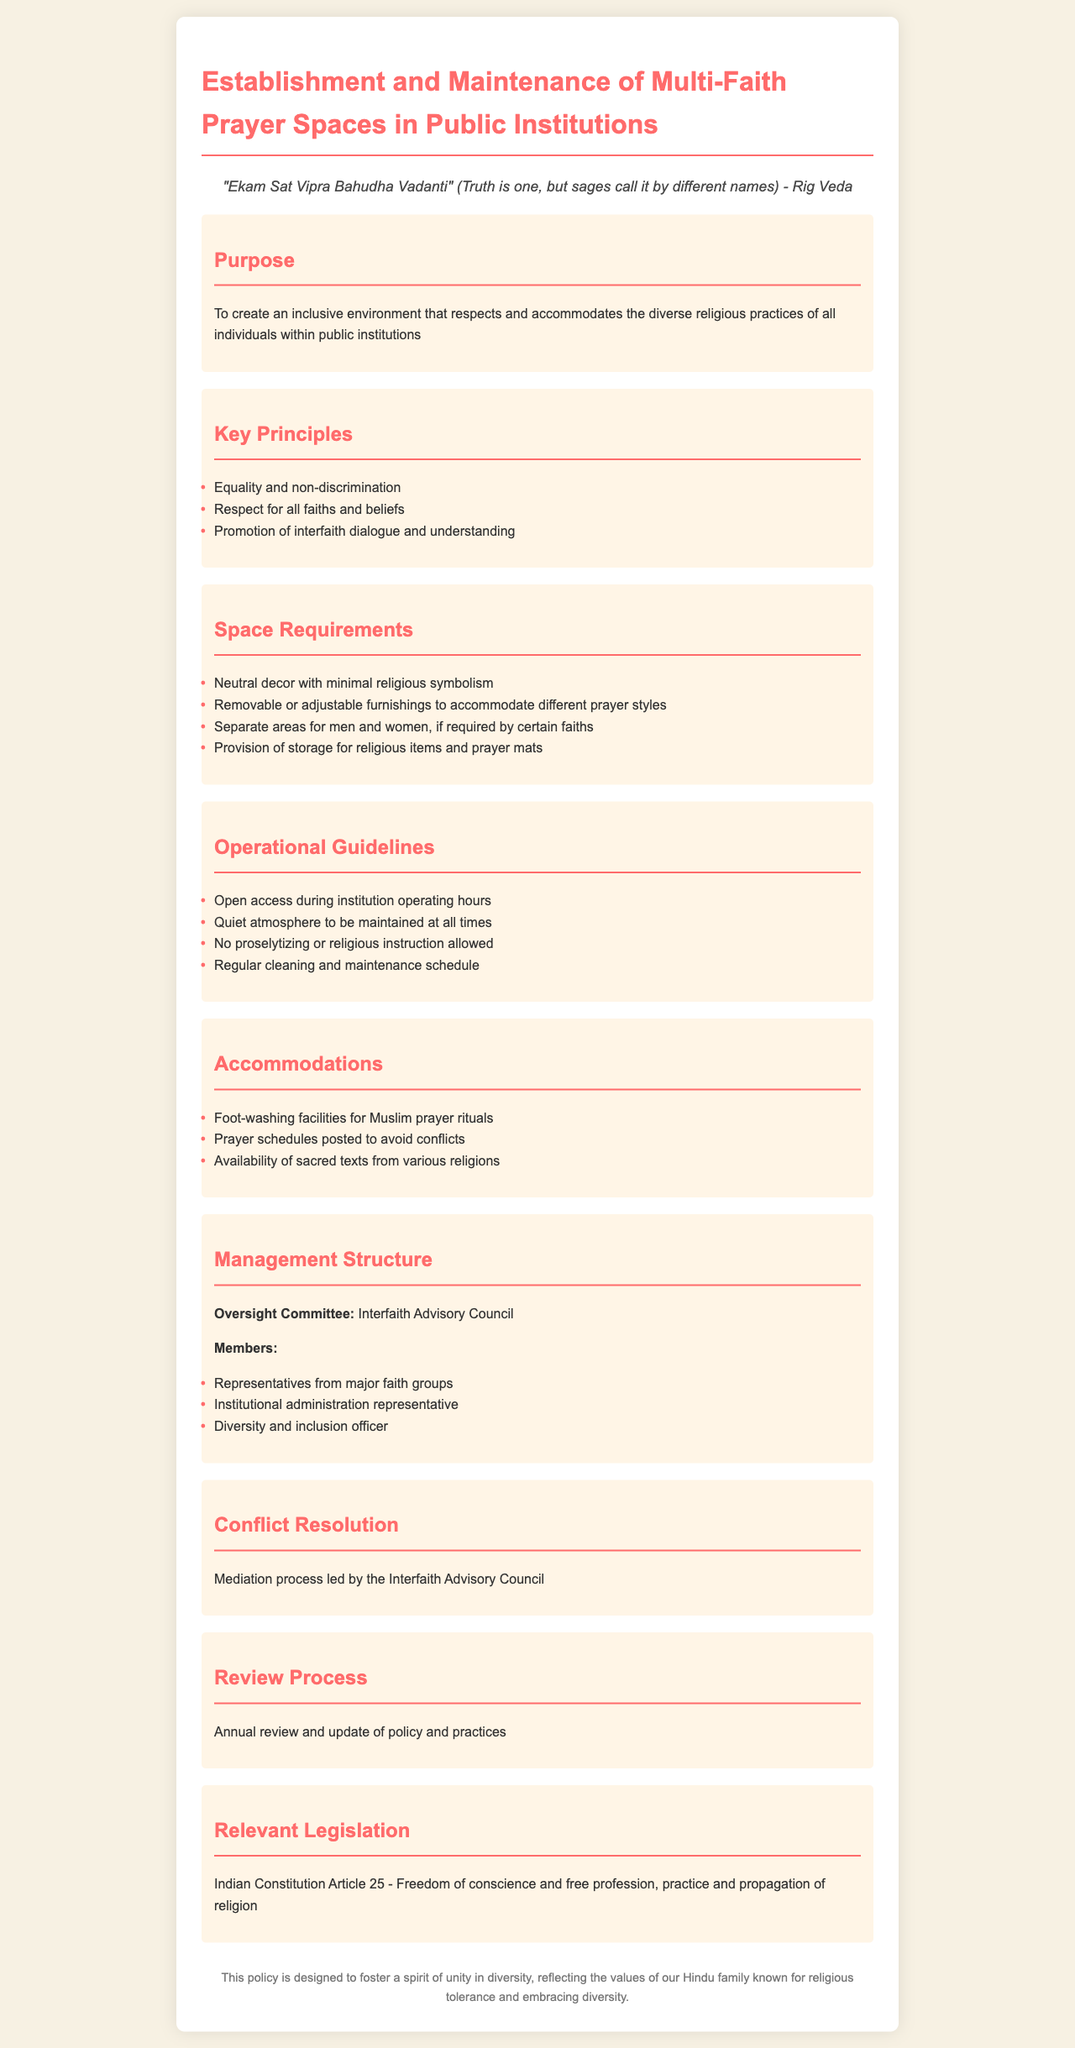What is the purpose of the policy? The purpose section describes the main objective of this policy, which is to create an inclusive environment that respects and accommodates diverse religious practices within public institutions.
Answer: To create an inclusive environment What does the quote in the document reference? The quote refers to the idea from the Rig Veda that while there are various names for the truth, it remains singular, emphasizing respect for all faiths.
Answer: Truth is one Who manages the prayer spaces? The management structure section specifies the oversight committee responsible for the prayer spaces, which is the Interfaith Advisory Council.
Answer: Interfaith Advisory Council What must be maintained at all times in the prayer space? The operational guidelines highlight the importance of a specific atmosphere that must be preserved in the space.
Answer: Quiet atmosphere How often is the policy reviewed? The review process section of the document mentions how frequently the policy and its practices are evaluated and updated.
Answer: Annual review What should be avoided during the use of the prayer space? The operational guidelines specify restrictions on certain activities to maintain the purpose of the prayer spaces.
Answer: No proselytizing What facilities are provided for Muslim prayer rituals? The accommodations section outlines specific provisions that are made to cater to particular religious practices.
Answer: Foot-washing facilities What is a key principle of the policy? The key principles section lists essential values that guide the establishment and maintenance of the multi-faith prayer space.
Answer: Equality and non-discrimination 